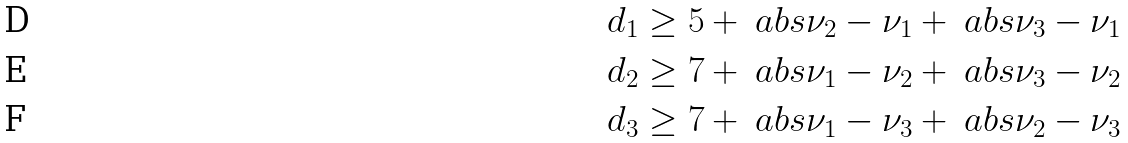<formula> <loc_0><loc_0><loc_500><loc_500>d _ { 1 } & \geq 5 + \ a b s { \nu _ { 2 } - \nu _ { 1 } } + \ a b s { \nu _ { 3 } - \nu _ { 1 } } \\ d _ { 2 } & \geq 7 + \ a b s { \nu _ { 1 } - \nu _ { 2 } } + \ a b s { \nu _ { 3 } - \nu _ { 2 } } \\ d _ { 3 } & \geq 7 + \ a b s { \nu _ { 1 } - \nu _ { 3 } } + \ a b s { \nu _ { 2 } - \nu _ { 3 } }</formula> 